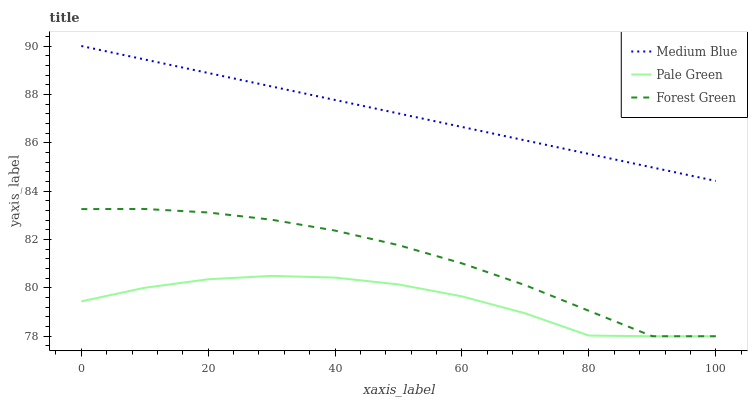Does Pale Green have the minimum area under the curve?
Answer yes or no. Yes. Does Medium Blue have the maximum area under the curve?
Answer yes or no. Yes. Does Medium Blue have the minimum area under the curve?
Answer yes or no. No. Does Pale Green have the maximum area under the curve?
Answer yes or no. No. Is Medium Blue the smoothest?
Answer yes or no. Yes. Is Pale Green the roughest?
Answer yes or no. Yes. Is Pale Green the smoothest?
Answer yes or no. No. Is Medium Blue the roughest?
Answer yes or no. No. Does Medium Blue have the lowest value?
Answer yes or no. No. Does Pale Green have the highest value?
Answer yes or no. No. Is Pale Green less than Medium Blue?
Answer yes or no. Yes. Is Medium Blue greater than Forest Green?
Answer yes or no. Yes. Does Pale Green intersect Medium Blue?
Answer yes or no. No. 